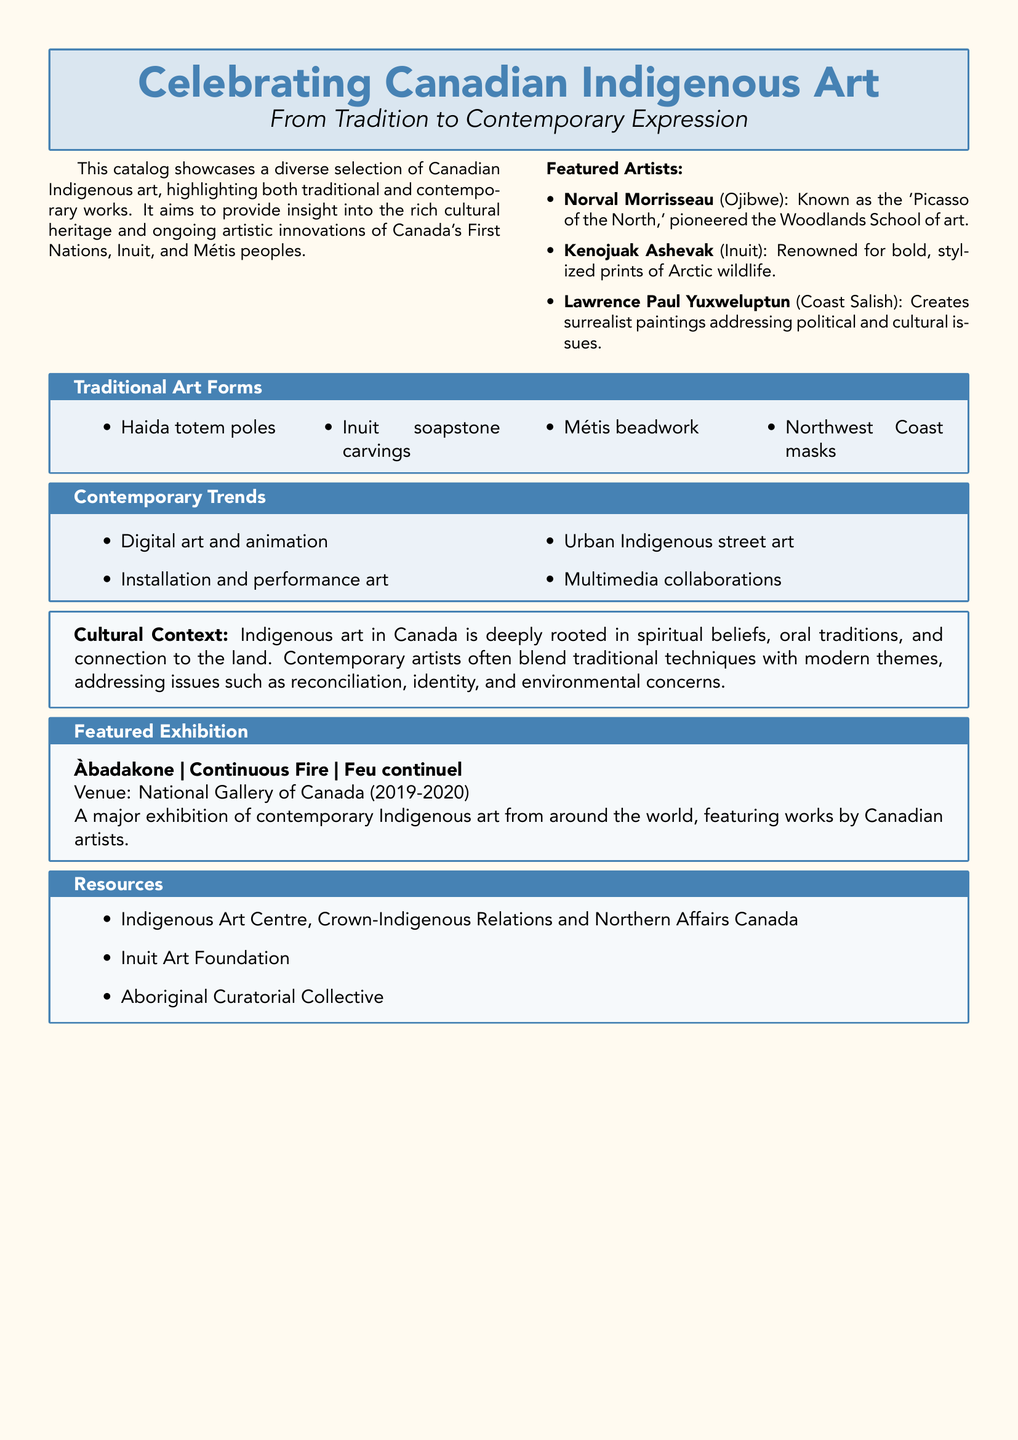What is the title of the catalog? The title of the catalog is prominently displayed at the beginning, focusing on Canadian Indigenous art.
Answer: Celebrating Canadian Indigenous Art Who is known as the 'Picasso of the North'? This artist's biography highlights their significant contribution to the Woodlands School of art.
Answer: Norval Morrisseau What form of traditional art is associated with the Métis? The traditional art forms section lists various cultural expressions, including beadwork specific to a group.
Answer: Beadwork What contemporary trend involves urban environments? The catalog discusses current artistic practices, particularly highlighting one that relates to city life.
Answer: Urban Indigenous street art Where was the featured exhibition held? The location for the major exhibition of contemporary Indigenous art is specified in the exhibition details.
Answer: National Gallery of Canada What year did the Àbadakone exhibition take place? The timeframe for the exhibition is indicated in the featured exhibition description, specifying two sequential years.
Answer: 2019-2020 What types of contemporary art are highlighted in the catalog? The contemporary trends section lists various modern forms of artistic expression that are currently popular.
Answer: Digital art and animation What is a key focus of Indigenous art in Canada? The cultural context section describes essential themes that underlie Indigenous artwork in the region.
Answer: Connection to the land How many featured artists are mentioned in the document? The list of featured artists provides a count, giving an idea of the breadth of representation.
Answer: Three 